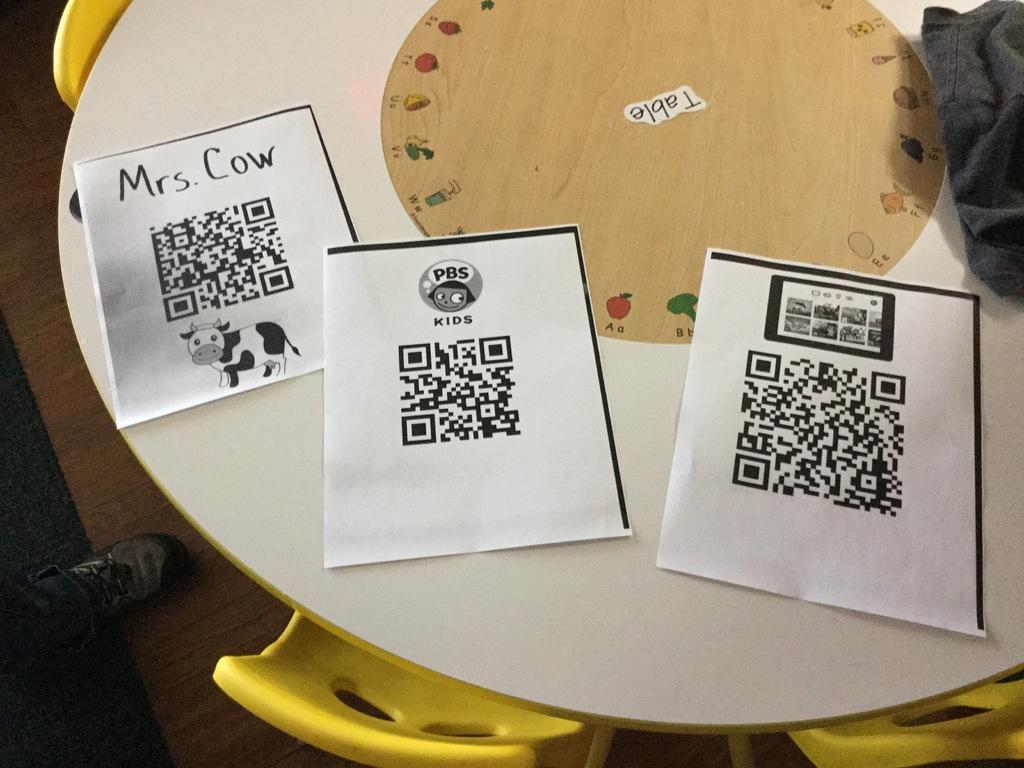Can you describe this image briefly? In the picture we can see a table on the wooden mat and some chairs around it which are yellow in color and on the table, we can see some papers with some prints on it and a person's leg with a shoe on the wooden mat. 